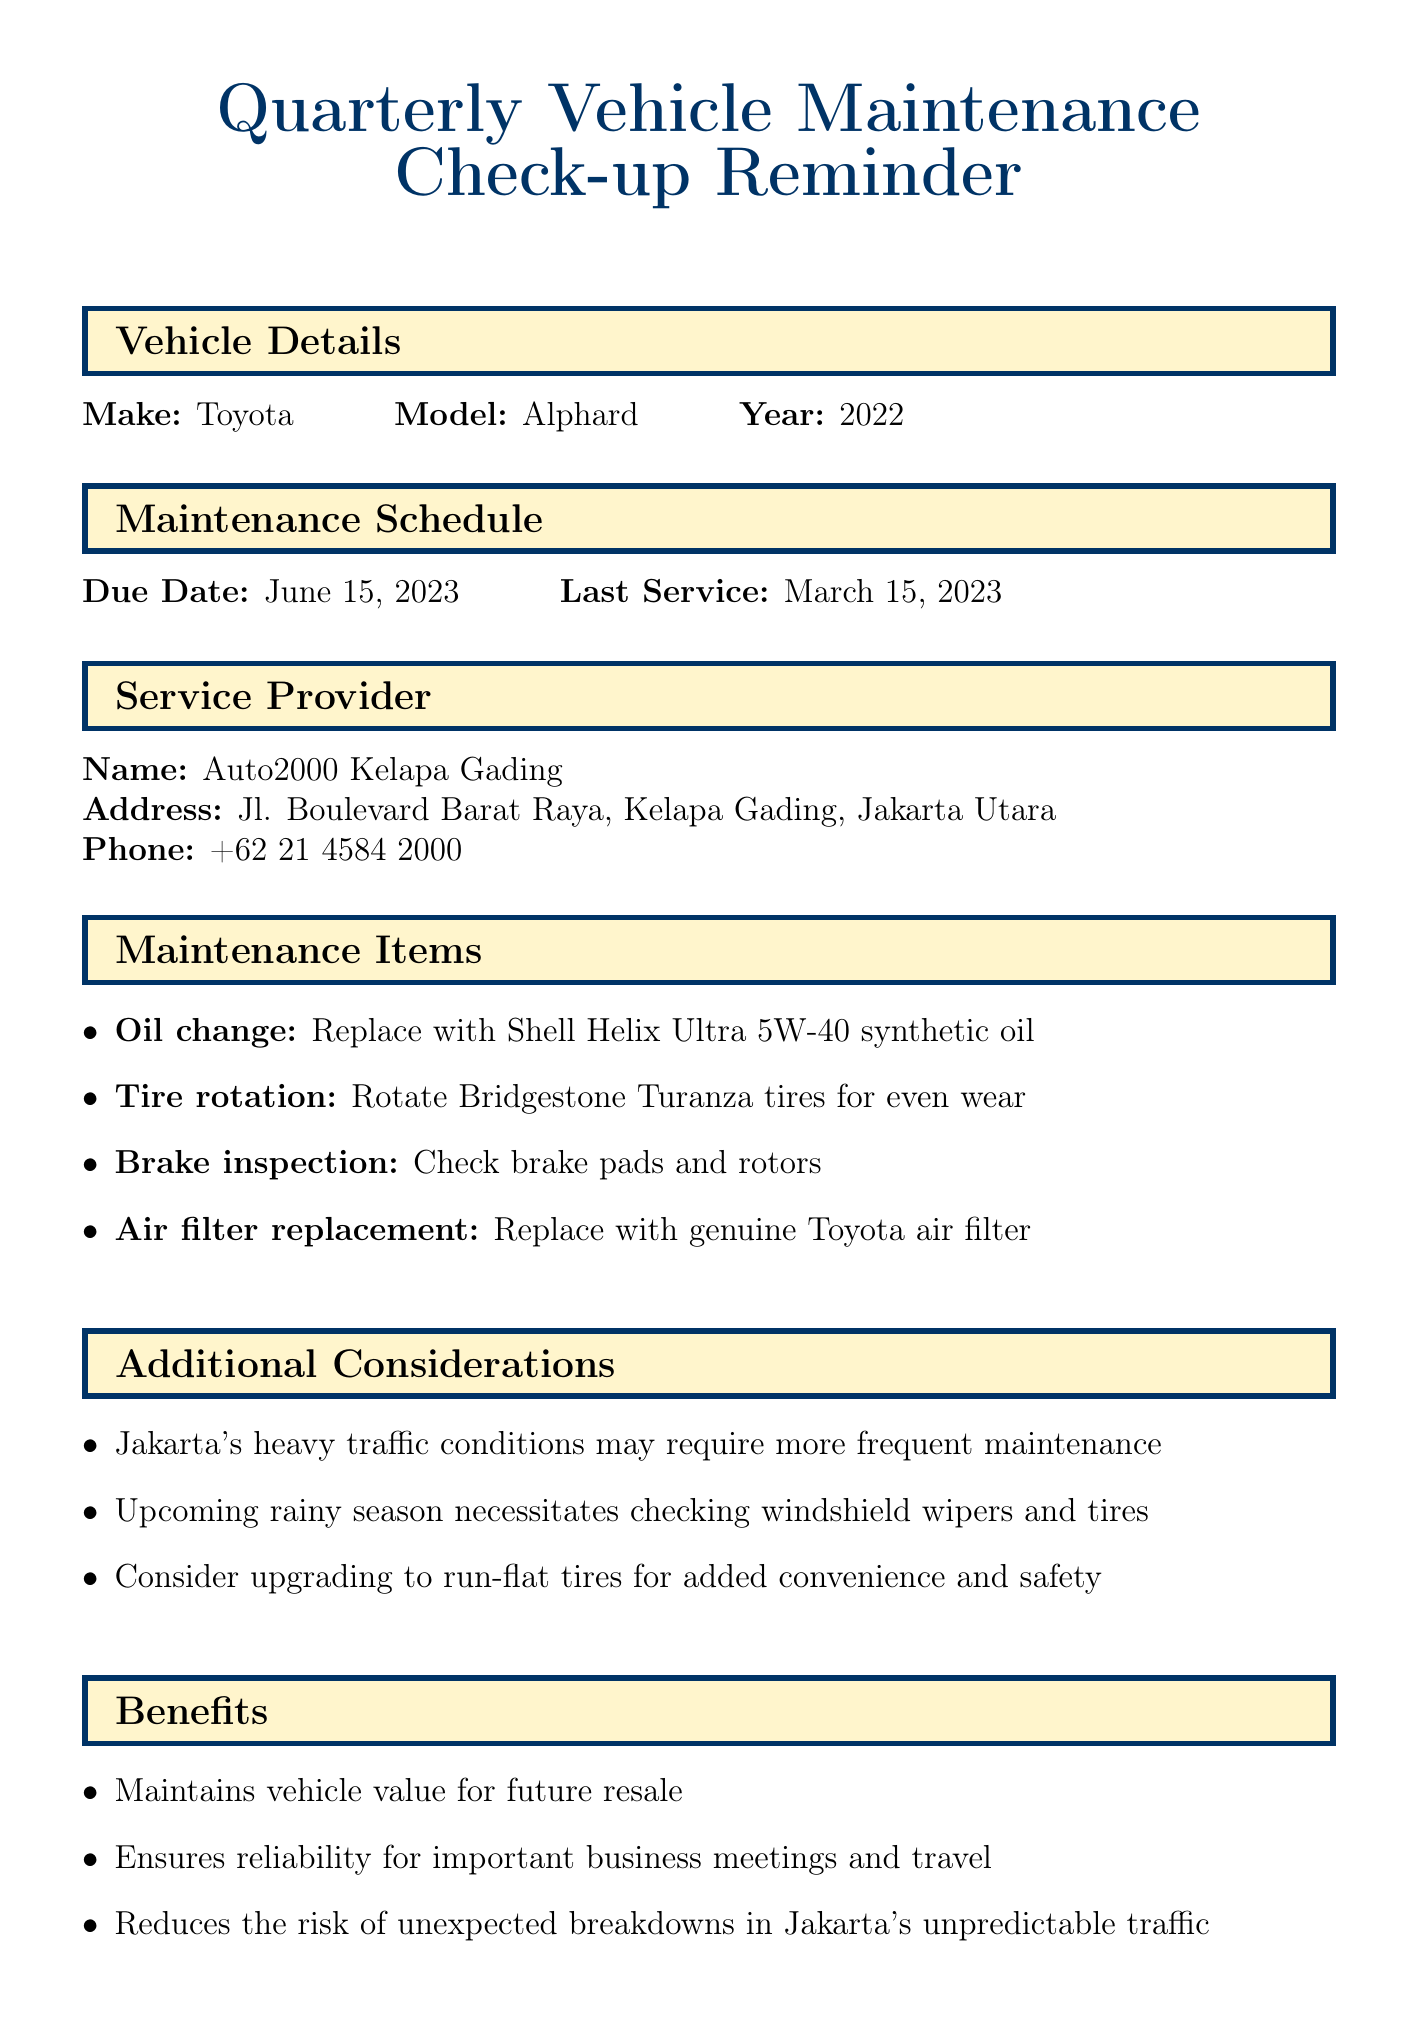What is the due date for the maintenance check-up? The due date is specified in the maintenance schedule section of the document.
Answer: June 15, 2023 Who is the service provider? The name of the service provider is mentioned in the service provider section of the document.
Answer: Auto2000 Kelapa Gading What oil should be used for the oil change? The document provides details about the oil to be used in the maintenance items section.
Answer: Shell Helix Ultra 5W-40 synthetic oil What is one of the benefits of the maintenance check-up? Several benefits are listed in the benefits section, indicating the importance of the vehicle check-up.
Answer: Reduces the risk of unexpected breakdowns in Jakarta's unpredictable traffic What are the additional considerations mentioned? The additional considerations section outlines important points related to upcoming conditions that need attention.
Answer: Jakarta's heavy traffic conditions may require more frequent maintenance Which maintenance item aims to improve vehicle handling? The task related to vehicle handling is found in the maintenance items section.
Answer: Tire rotation How can I book an appointment? The document provides several options for booking an appointment in the appointment booking section.
Answer: Online booking, email, WhatsApp What club offers priority scheduling as a benefit? The loyalty program section identifies which club provides this benefit.
Answer: Auto2000 VIP Club 